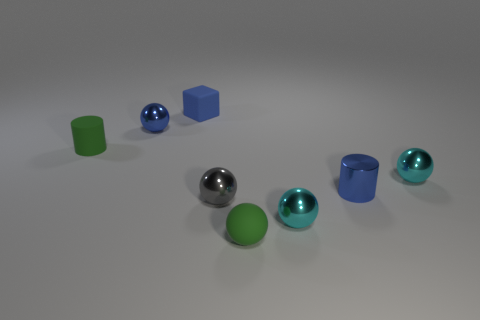What number of objects are either small matte objects that are left of the small gray metal sphere or small cyan shiny balls?
Your answer should be compact. 4. What number of blue objects are spheres or rubber cylinders?
Your answer should be very brief. 1. How many other things are there of the same color as the small matte cylinder?
Offer a terse response. 1. Are there fewer tiny gray metallic balls that are to the left of the small gray metallic object than large blue spheres?
Your answer should be very brief. No. There is a metal sphere that is on the right side of the blue thing that is in front of the cylinder to the left of the gray thing; what is its color?
Make the answer very short. Cyan. Is there any other thing that has the same material as the small green sphere?
Offer a terse response. Yes. What is the size of the blue object that is the same shape as the tiny gray thing?
Your answer should be compact. Small. Are there fewer tiny metallic things that are on the left side of the tiny green sphere than tiny blocks that are on the left side of the tiny gray object?
Make the answer very short. No. There is a tiny blue object that is both in front of the block and right of the small blue sphere; what is its shape?
Your response must be concise. Cylinder. There is a blue cube that is made of the same material as the tiny green ball; what is its size?
Offer a terse response. Small. 